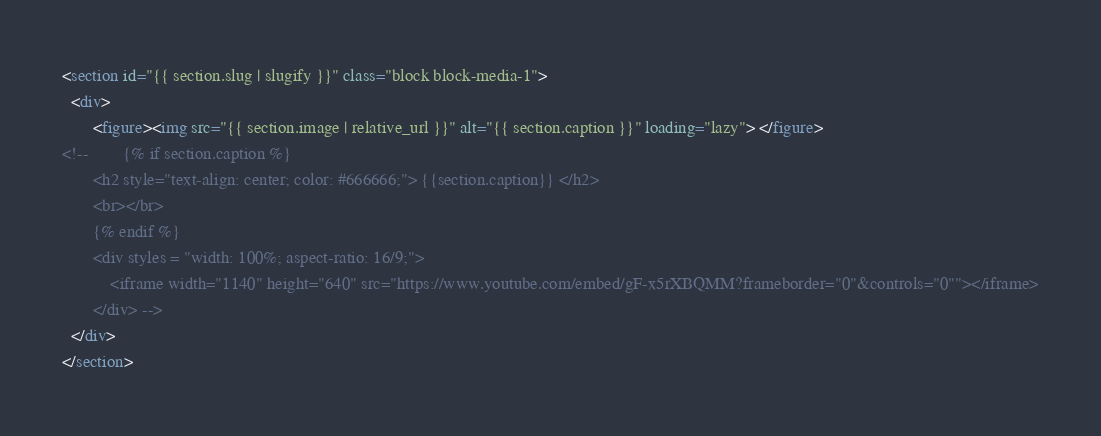Convert code to text. <code><loc_0><loc_0><loc_500><loc_500><_HTML_><section id="{{ section.slug | slugify }}" class="block block-media-1">
  <div>
       <figure><img src="{{ section.image | relative_url }}" alt="{{ section.caption }}" loading="lazy"> </figure>
<!--        {% if section.caption %}
       <h2 style="text-align: center; color: #666666;"> {{section.caption}} </h2>
       <br></br>
       {% endif %}
       <div styles = "width: 100%; aspect-ratio: 16/9;">
           <iframe width="1140" height="640" src="https://www.youtube.com/embed/gF-x5rXBQMM?frameborder="0"&controls="0""></iframe>
       </div> -->
  </div>
</section>
</code> 